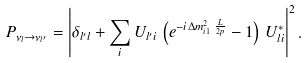Convert formula to latex. <formula><loc_0><loc_0><loc_500><loc_500>P _ { \nu _ { l } \to \nu _ { l ^ { \prime } } } = \left | \delta _ { l ^ { \prime } l } + \sum _ { i } U _ { l ^ { \prime } i } \, \left ( e ^ { - i \, \Delta { m } ^ { 2 } _ { i 1 } \, \frac { L } { 2 p } } - 1 \right ) \, U _ { l i } ^ { * } \right | ^ { 2 } .</formula> 